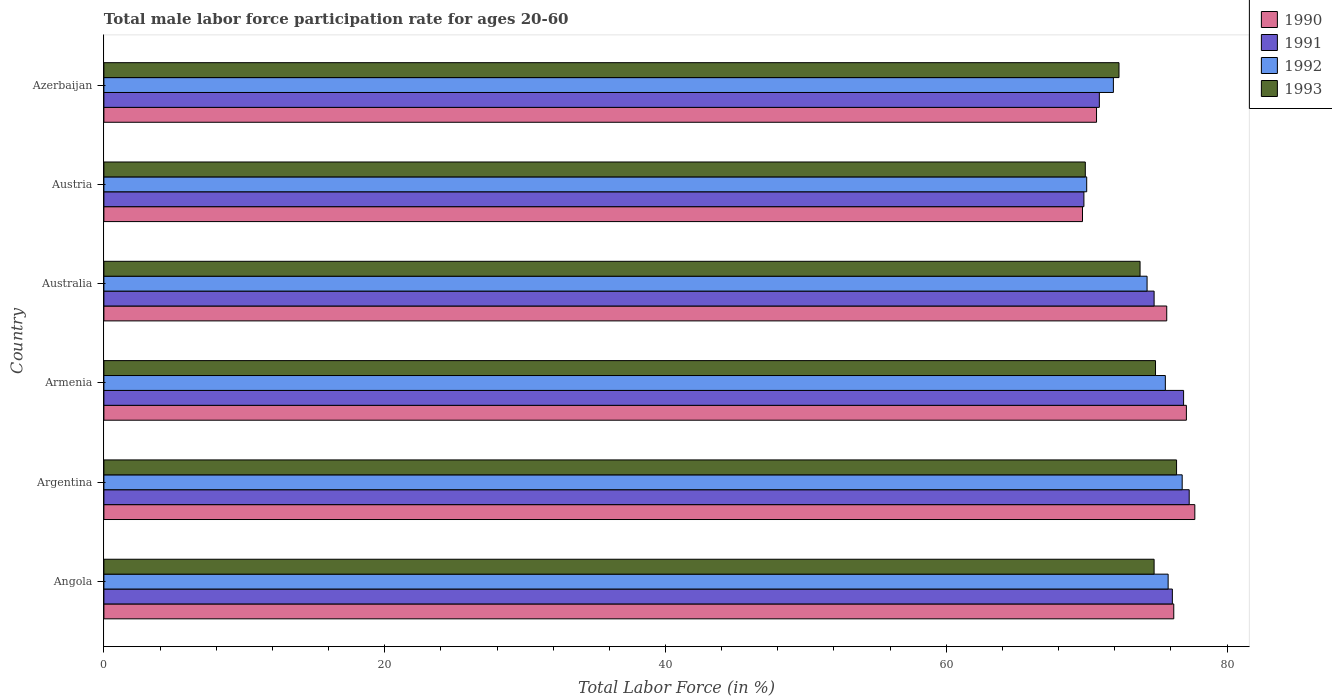How many groups of bars are there?
Give a very brief answer. 6. Are the number of bars per tick equal to the number of legend labels?
Give a very brief answer. Yes. Are the number of bars on each tick of the Y-axis equal?
Your answer should be compact. Yes. What is the label of the 1st group of bars from the top?
Provide a succinct answer. Azerbaijan. In how many cases, is the number of bars for a given country not equal to the number of legend labels?
Offer a very short reply. 0. Across all countries, what is the maximum male labor force participation rate in 1993?
Your answer should be very brief. 76.4. Across all countries, what is the minimum male labor force participation rate in 1991?
Provide a succinct answer. 69.8. In which country was the male labor force participation rate in 1991 maximum?
Keep it short and to the point. Argentina. What is the total male labor force participation rate in 1991 in the graph?
Your answer should be very brief. 445.8. What is the difference between the male labor force participation rate in 1991 in Argentina and that in Australia?
Keep it short and to the point. 2.5. What is the difference between the male labor force participation rate in 1991 in Azerbaijan and the male labor force participation rate in 1990 in Armenia?
Keep it short and to the point. -6.2. What is the average male labor force participation rate in 1990 per country?
Your answer should be compact. 74.52. What is the difference between the male labor force participation rate in 1993 and male labor force participation rate in 1992 in Australia?
Offer a terse response. -0.5. In how many countries, is the male labor force participation rate in 1990 greater than 28 %?
Provide a succinct answer. 6. What is the ratio of the male labor force participation rate in 1992 in Angola to that in Azerbaijan?
Provide a succinct answer. 1.05. Is the male labor force participation rate in 1992 in Angola less than that in Australia?
Your answer should be compact. No. What is the difference between the highest and the second highest male labor force participation rate in 1991?
Ensure brevity in your answer.  0.4. What is the difference between the highest and the lowest male labor force participation rate in 1991?
Keep it short and to the point. 7.5. Is the sum of the male labor force participation rate in 1992 in Angola and Austria greater than the maximum male labor force participation rate in 1991 across all countries?
Your answer should be compact. Yes. Are all the bars in the graph horizontal?
Make the answer very short. Yes. What is the difference between two consecutive major ticks on the X-axis?
Keep it short and to the point. 20. Does the graph contain grids?
Your answer should be very brief. No. Where does the legend appear in the graph?
Offer a very short reply. Top right. How many legend labels are there?
Provide a succinct answer. 4. How are the legend labels stacked?
Your answer should be very brief. Vertical. What is the title of the graph?
Keep it short and to the point. Total male labor force participation rate for ages 20-60. Does "1986" appear as one of the legend labels in the graph?
Offer a terse response. No. What is the label or title of the X-axis?
Ensure brevity in your answer.  Total Labor Force (in %). What is the label or title of the Y-axis?
Your response must be concise. Country. What is the Total Labor Force (in %) in 1990 in Angola?
Keep it short and to the point. 76.2. What is the Total Labor Force (in %) in 1991 in Angola?
Give a very brief answer. 76.1. What is the Total Labor Force (in %) in 1992 in Angola?
Provide a short and direct response. 75.8. What is the Total Labor Force (in %) in 1993 in Angola?
Make the answer very short. 74.8. What is the Total Labor Force (in %) of 1990 in Argentina?
Your answer should be very brief. 77.7. What is the Total Labor Force (in %) in 1991 in Argentina?
Ensure brevity in your answer.  77.3. What is the Total Labor Force (in %) in 1992 in Argentina?
Your answer should be very brief. 76.8. What is the Total Labor Force (in %) in 1993 in Argentina?
Ensure brevity in your answer.  76.4. What is the Total Labor Force (in %) of 1990 in Armenia?
Provide a short and direct response. 77.1. What is the Total Labor Force (in %) in 1991 in Armenia?
Ensure brevity in your answer.  76.9. What is the Total Labor Force (in %) in 1992 in Armenia?
Ensure brevity in your answer.  75.6. What is the Total Labor Force (in %) of 1993 in Armenia?
Give a very brief answer. 74.9. What is the Total Labor Force (in %) of 1990 in Australia?
Keep it short and to the point. 75.7. What is the Total Labor Force (in %) of 1991 in Australia?
Give a very brief answer. 74.8. What is the Total Labor Force (in %) of 1992 in Australia?
Your response must be concise. 74.3. What is the Total Labor Force (in %) of 1993 in Australia?
Your answer should be compact. 73.8. What is the Total Labor Force (in %) in 1990 in Austria?
Make the answer very short. 69.7. What is the Total Labor Force (in %) in 1991 in Austria?
Offer a very short reply. 69.8. What is the Total Labor Force (in %) in 1992 in Austria?
Ensure brevity in your answer.  70. What is the Total Labor Force (in %) of 1993 in Austria?
Your answer should be very brief. 69.9. What is the Total Labor Force (in %) in 1990 in Azerbaijan?
Make the answer very short. 70.7. What is the Total Labor Force (in %) of 1991 in Azerbaijan?
Give a very brief answer. 70.9. What is the Total Labor Force (in %) of 1992 in Azerbaijan?
Your answer should be very brief. 71.9. What is the Total Labor Force (in %) in 1993 in Azerbaijan?
Offer a terse response. 72.3. Across all countries, what is the maximum Total Labor Force (in %) in 1990?
Give a very brief answer. 77.7. Across all countries, what is the maximum Total Labor Force (in %) of 1991?
Offer a terse response. 77.3. Across all countries, what is the maximum Total Labor Force (in %) in 1992?
Give a very brief answer. 76.8. Across all countries, what is the maximum Total Labor Force (in %) in 1993?
Give a very brief answer. 76.4. Across all countries, what is the minimum Total Labor Force (in %) in 1990?
Give a very brief answer. 69.7. Across all countries, what is the minimum Total Labor Force (in %) in 1991?
Provide a short and direct response. 69.8. Across all countries, what is the minimum Total Labor Force (in %) in 1993?
Keep it short and to the point. 69.9. What is the total Total Labor Force (in %) of 1990 in the graph?
Keep it short and to the point. 447.1. What is the total Total Labor Force (in %) of 1991 in the graph?
Offer a terse response. 445.8. What is the total Total Labor Force (in %) in 1992 in the graph?
Your response must be concise. 444.4. What is the total Total Labor Force (in %) of 1993 in the graph?
Make the answer very short. 442.1. What is the difference between the Total Labor Force (in %) of 1990 in Angola and that in Argentina?
Provide a succinct answer. -1.5. What is the difference between the Total Labor Force (in %) of 1992 in Angola and that in Argentina?
Your answer should be compact. -1. What is the difference between the Total Labor Force (in %) in 1991 in Angola and that in Armenia?
Offer a very short reply. -0.8. What is the difference between the Total Labor Force (in %) in 1992 in Angola and that in Australia?
Your response must be concise. 1.5. What is the difference between the Total Labor Force (in %) of 1990 in Angola and that in Austria?
Keep it short and to the point. 6.5. What is the difference between the Total Labor Force (in %) in 1991 in Angola and that in Austria?
Your response must be concise. 6.3. What is the difference between the Total Labor Force (in %) of 1992 in Angola and that in Austria?
Ensure brevity in your answer.  5.8. What is the difference between the Total Labor Force (in %) of 1993 in Angola and that in Austria?
Provide a succinct answer. 4.9. What is the difference between the Total Labor Force (in %) of 1990 in Angola and that in Azerbaijan?
Offer a terse response. 5.5. What is the difference between the Total Labor Force (in %) of 1991 in Angola and that in Azerbaijan?
Your answer should be very brief. 5.2. What is the difference between the Total Labor Force (in %) of 1992 in Angola and that in Azerbaijan?
Your answer should be very brief. 3.9. What is the difference between the Total Labor Force (in %) in 1990 in Argentina and that in Australia?
Your response must be concise. 2. What is the difference between the Total Labor Force (in %) of 1991 in Argentina and that in Australia?
Your answer should be very brief. 2.5. What is the difference between the Total Labor Force (in %) of 1992 in Argentina and that in Australia?
Ensure brevity in your answer.  2.5. What is the difference between the Total Labor Force (in %) in 1993 in Argentina and that in Australia?
Offer a very short reply. 2.6. What is the difference between the Total Labor Force (in %) of 1990 in Argentina and that in Austria?
Give a very brief answer. 8. What is the difference between the Total Labor Force (in %) of 1991 in Argentina and that in Austria?
Your answer should be compact. 7.5. What is the difference between the Total Labor Force (in %) in 1992 in Argentina and that in Austria?
Provide a short and direct response. 6.8. What is the difference between the Total Labor Force (in %) of 1992 in Argentina and that in Azerbaijan?
Offer a terse response. 4.9. What is the difference between the Total Labor Force (in %) of 1990 in Armenia and that in Austria?
Offer a very short reply. 7.4. What is the difference between the Total Labor Force (in %) in 1991 in Armenia and that in Austria?
Ensure brevity in your answer.  7.1. What is the difference between the Total Labor Force (in %) of 1992 in Armenia and that in Austria?
Offer a terse response. 5.6. What is the difference between the Total Labor Force (in %) in 1991 in Armenia and that in Azerbaijan?
Offer a very short reply. 6. What is the difference between the Total Labor Force (in %) of 1992 in Armenia and that in Azerbaijan?
Offer a very short reply. 3.7. What is the difference between the Total Labor Force (in %) in 1993 in Armenia and that in Azerbaijan?
Provide a succinct answer. 2.6. What is the difference between the Total Labor Force (in %) in 1990 in Australia and that in Austria?
Ensure brevity in your answer.  6. What is the difference between the Total Labor Force (in %) of 1991 in Australia and that in Austria?
Provide a succinct answer. 5. What is the difference between the Total Labor Force (in %) of 1992 in Australia and that in Austria?
Give a very brief answer. 4.3. What is the difference between the Total Labor Force (in %) of 1992 in Australia and that in Azerbaijan?
Provide a short and direct response. 2.4. What is the difference between the Total Labor Force (in %) in 1993 in Australia and that in Azerbaijan?
Keep it short and to the point. 1.5. What is the difference between the Total Labor Force (in %) of 1990 in Austria and that in Azerbaijan?
Your answer should be compact. -1. What is the difference between the Total Labor Force (in %) of 1991 in Austria and that in Azerbaijan?
Provide a succinct answer. -1.1. What is the difference between the Total Labor Force (in %) of 1990 in Angola and the Total Labor Force (in %) of 1991 in Argentina?
Provide a short and direct response. -1.1. What is the difference between the Total Labor Force (in %) of 1990 in Angola and the Total Labor Force (in %) of 1992 in Argentina?
Your response must be concise. -0.6. What is the difference between the Total Labor Force (in %) of 1990 in Angola and the Total Labor Force (in %) of 1993 in Argentina?
Give a very brief answer. -0.2. What is the difference between the Total Labor Force (in %) in 1991 in Angola and the Total Labor Force (in %) in 1992 in Argentina?
Ensure brevity in your answer.  -0.7. What is the difference between the Total Labor Force (in %) of 1991 in Angola and the Total Labor Force (in %) of 1993 in Argentina?
Offer a very short reply. -0.3. What is the difference between the Total Labor Force (in %) in 1992 in Angola and the Total Labor Force (in %) in 1993 in Argentina?
Keep it short and to the point. -0.6. What is the difference between the Total Labor Force (in %) of 1990 in Angola and the Total Labor Force (in %) of 1991 in Armenia?
Make the answer very short. -0.7. What is the difference between the Total Labor Force (in %) of 1990 in Angola and the Total Labor Force (in %) of 1993 in Australia?
Keep it short and to the point. 2.4. What is the difference between the Total Labor Force (in %) in 1991 in Angola and the Total Labor Force (in %) in 1992 in Australia?
Your response must be concise. 1.8. What is the difference between the Total Labor Force (in %) in 1992 in Angola and the Total Labor Force (in %) in 1993 in Australia?
Offer a very short reply. 2. What is the difference between the Total Labor Force (in %) in 1990 in Angola and the Total Labor Force (in %) in 1991 in Azerbaijan?
Provide a short and direct response. 5.3. What is the difference between the Total Labor Force (in %) of 1992 in Angola and the Total Labor Force (in %) of 1993 in Azerbaijan?
Your answer should be very brief. 3.5. What is the difference between the Total Labor Force (in %) of 1990 in Argentina and the Total Labor Force (in %) of 1992 in Armenia?
Your response must be concise. 2.1. What is the difference between the Total Labor Force (in %) of 1990 in Argentina and the Total Labor Force (in %) of 1993 in Armenia?
Your response must be concise. 2.8. What is the difference between the Total Labor Force (in %) of 1991 in Argentina and the Total Labor Force (in %) of 1993 in Armenia?
Offer a very short reply. 2.4. What is the difference between the Total Labor Force (in %) in 1990 in Argentina and the Total Labor Force (in %) in 1993 in Australia?
Provide a short and direct response. 3.9. What is the difference between the Total Labor Force (in %) in 1990 in Argentina and the Total Labor Force (in %) in 1992 in Austria?
Give a very brief answer. 7.7. What is the difference between the Total Labor Force (in %) in 1991 in Argentina and the Total Labor Force (in %) in 1992 in Austria?
Offer a terse response. 7.3. What is the difference between the Total Labor Force (in %) of 1991 in Argentina and the Total Labor Force (in %) of 1993 in Austria?
Make the answer very short. 7.4. What is the difference between the Total Labor Force (in %) of 1992 in Argentina and the Total Labor Force (in %) of 1993 in Austria?
Offer a terse response. 6.9. What is the difference between the Total Labor Force (in %) of 1990 in Argentina and the Total Labor Force (in %) of 1992 in Azerbaijan?
Offer a terse response. 5.8. What is the difference between the Total Labor Force (in %) in 1992 in Argentina and the Total Labor Force (in %) in 1993 in Azerbaijan?
Offer a terse response. 4.5. What is the difference between the Total Labor Force (in %) in 1990 in Armenia and the Total Labor Force (in %) in 1993 in Australia?
Your answer should be very brief. 3.3. What is the difference between the Total Labor Force (in %) of 1991 in Armenia and the Total Labor Force (in %) of 1993 in Australia?
Offer a terse response. 3.1. What is the difference between the Total Labor Force (in %) of 1990 in Armenia and the Total Labor Force (in %) of 1993 in Austria?
Your response must be concise. 7.2. What is the difference between the Total Labor Force (in %) of 1991 in Armenia and the Total Labor Force (in %) of 1993 in Austria?
Give a very brief answer. 7. What is the difference between the Total Labor Force (in %) of 1992 in Armenia and the Total Labor Force (in %) of 1993 in Austria?
Offer a terse response. 5.7. What is the difference between the Total Labor Force (in %) in 1990 in Armenia and the Total Labor Force (in %) in 1991 in Azerbaijan?
Provide a succinct answer. 6.2. What is the difference between the Total Labor Force (in %) in 1992 in Armenia and the Total Labor Force (in %) in 1993 in Azerbaijan?
Your answer should be very brief. 3.3. What is the difference between the Total Labor Force (in %) in 1991 in Australia and the Total Labor Force (in %) in 1993 in Austria?
Keep it short and to the point. 4.9. What is the difference between the Total Labor Force (in %) in 1992 in Australia and the Total Labor Force (in %) in 1993 in Austria?
Provide a succinct answer. 4.4. What is the difference between the Total Labor Force (in %) of 1990 in Australia and the Total Labor Force (in %) of 1992 in Azerbaijan?
Offer a very short reply. 3.8. What is the difference between the Total Labor Force (in %) of 1990 in Australia and the Total Labor Force (in %) of 1993 in Azerbaijan?
Give a very brief answer. 3.4. What is the difference between the Total Labor Force (in %) in 1991 in Australia and the Total Labor Force (in %) in 1992 in Azerbaijan?
Your response must be concise. 2.9. What is the difference between the Total Labor Force (in %) of 1992 in Australia and the Total Labor Force (in %) of 1993 in Azerbaijan?
Your answer should be compact. 2. What is the difference between the Total Labor Force (in %) of 1990 in Austria and the Total Labor Force (in %) of 1991 in Azerbaijan?
Your answer should be very brief. -1.2. What is the difference between the Total Labor Force (in %) of 1991 in Austria and the Total Labor Force (in %) of 1992 in Azerbaijan?
Your response must be concise. -2.1. What is the average Total Labor Force (in %) in 1990 per country?
Offer a terse response. 74.52. What is the average Total Labor Force (in %) in 1991 per country?
Provide a short and direct response. 74.3. What is the average Total Labor Force (in %) in 1992 per country?
Ensure brevity in your answer.  74.07. What is the average Total Labor Force (in %) in 1993 per country?
Offer a terse response. 73.68. What is the difference between the Total Labor Force (in %) in 1990 and Total Labor Force (in %) in 1991 in Angola?
Your answer should be very brief. 0.1. What is the difference between the Total Labor Force (in %) of 1990 and Total Labor Force (in %) of 1992 in Angola?
Provide a succinct answer. 0.4. What is the difference between the Total Labor Force (in %) of 1991 and Total Labor Force (in %) of 1993 in Angola?
Your answer should be very brief. 1.3. What is the difference between the Total Labor Force (in %) in 1990 and Total Labor Force (in %) in 1992 in Argentina?
Ensure brevity in your answer.  0.9. What is the difference between the Total Labor Force (in %) of 1991 and Total Labor Force (in %) of 1992 in Argentina?
Provide a short and direct response. 0.5. What is the difference between the Total Labor Force (in %) in 1990 and Total Labor Force (in %) in 1991 in Armenia?
Ensure brevity in your answer.  0.2. What is the difference between the Total Labor Force (in %) of 1991 and Total Labor Force (in %) of 1993 in Armenia?
Provide a succinct answer. 2. What is the difference between the Total Labor Force (in %) in 1990 and Total Labor Force (in %) in 1993 in Australia?
Offer a very short reply. 1.9. What is the difference between the Total Labor Force (in %) of 1991 and Total Labor Force (in %) of 1992 in Australia?
Make the answer very short. 0.5. What is the difference between the Total Labor Force (in %) in 1991 and Total Labor Force (in %) in 1993 in Australia?
Keep it short and to the point. 1. What is the difference between the Total Labor Force (in %) of 1992 and Total Labor Force (in %) of 1993 in Australia?
Offer a terse response. 0.5. What is the difference between the Total Labor Force (in %) of 1990 and Total Labor Force (in %) of 1992 in Austria?
Make the answer very short. -0.3. What is the difference between the Total Labor Force (in %) of 1990 and Total Labor Force (in %) of 1991 in Azerbaijan?
Give a very brief answer. -0.2. What is the difference between the Total Labor Force (in %) in 1990 and Total Labor Force (in %) in 1992 in Azerbaijan?
Provide a succinct answer. -1.2. What is the difference between the Total Labor Force (in %) in 1991 and Total Labor Force (in %) in 1993 in Azerbaijan?
Your answer should be very brief. -1.4. What is the difference between the Total Labor Force (in %) in 1992 and Total Labor Force (in %) in 1993 in Azerbaijan?
Give a very brief answer. -0.4. What is the ratio of the Total Labor Force (in %) of 1990 in Angola to that in Argentina?
Provide a short and direct response. 0.98. What is the ratio of the Total Labor Force (in %) in 1991 in Angola to that in Argentina?
Make the answer very short. 0.98. What is the ratio of the Total Labor Force (in %) in 1993 in Angola to that in Argentina?
Your response must be concise. 0.98. What is the ratio of the Total Labor Force (in %) of 1990 in Angola to that in Armenia?
Offer a very short reply. 0.99. What is the ratio of the Total Labor Force (in %) of 1991 in Angola to that in Armenia?
Ensure brevity in your answer.  0.99. What is the ratio of the Total Labor Force (in %) of 1992 in Angola to that in Armenia?
Your answer should be compact. 1. What is the ratio of the Total Labor Force (in %) of 1993 in Angola to that in Armenia?
Provide a succinct answer. 1. What is the ratio of the Total Labor Force (in %) of 1990 in Angola to that in Australia?
Your answer should be compact. 1.01. What is the ratio of the Total Labor Force (in %) in 1991 in Angola to that in Australia?
Keep it short and to the point. 1.02. What is the ratio of the Total Labor Force (in %) of 1992 in Angola to that in Australia?
Your answer should be compact. 1.02. What is the ratio of the Total Labor Force (in %) in 1993 in Angola to that in Australia?
Make the answer very short. 1.01. What is the ratio of the Total Labor Force (in %) of 1990 in Angola to that in Austria?
Your answer should be compact. 1.09. What is the ratio of the Total Labor Force (in %) in 1991 in Angola to that in Austria?
Offer a terse response. 1.09. What is the ratio of the Total Labor Force (in %) of 1992 in Angola to that in Austria?
Offer a very short reply. 1.08. What is the ratio of the Total Labor Force (in %) in 1993 in Angola to that in Austria?
Your answer should be compact. 1.07. What is the ratio of the Total Labor Force (in %) in 1990 in Angola to that in Azerbaijan?
Your answer should be compact. 1.08. What is the ratio of the Total Labor Force (in %) in 1991 in Angola to that in Azerbaijan?
Your response must be concise. 1.07. What is the ratio of the Total Labor Force (in %) in 1992 in Angola to that in Azerbaijan?
Offer a terse response. 1.05. What is the ratio of the Total Labor Force (in %) in 1993 in Angola to that in Azerbaijan?
Ensure brevity in your answer.  1.03. What is the ratio of the Total Labor Force (in %) in 1991 in Argentina to that in Armenia?
Your answer should be very brief. 1.01. What is the ratio of the Total Labor Force (in %) in 1992 in Argentina to that in Armenia?
Offer a terse response. 1.02. What is the ratio of the Total Labor Force (in %) of 1993 in Argentina to that in Armenia?
Provide a short and direct response. 1.02. What is the ratio of the Total Labor Force (in %) in 1990 in Argentina to that in Australia?
Your answer should be very brief. 1.03. What is the ratio of the Total Labor Force (in %) in 1991 in Argentina to that in Australia?
Offer a very short reply. 1.03. What is the ratio of the Total Labor Force (in %) of 1992 in Argentina to that in Australia?
Keep it short and to the point. 1.03. What is the ratio of the Total Labor Force (in %) in 1993 in Argentina to that in Australia?
Offer a very short reply. 1.04. What is the ratio of the Total Labor Force (in %) of 1990 in Argentina to that in Austria?
Your response must be concise. 1.11. What is the ratio of the Total Labor Force (in %) of 1991 in Argentina to that in Austria?
Your answer should be very brief. 1.11. What is the ratio of the Total Labor Force (in %) of 1992 in Argentina to that in Austria?
Provide a succinct answer. 1.1. What is the ratio of the Total Labor Force (in %) in 1993 in Argentina to that in Austria?
Ensure brevity in your answer.  1.09. What is the ratio of the Total Labor Force (in %) of 1990 in Argentina to that in Azerbaijan?
Your answer should be compact. 1.1. What is the ratio of the Total Labor Force (in %) in 1991 in Argentina to that in Azerbaijan?
Offer a terse response. 1.09. What is the ratio of the Total Labor Force (in %) of 1992 in Argentina to that in Azerbaijan?
Provide a short and direct response. 1.07. What is the ratio of the Total Labor Force (in %) of 1993 in Argentina to that in Azerbaijan?
Make the answer very short. 1.06. What is the ratio of the Total Labor Force (in %) in 1990 in Armenia to that in Australia?
Keep it short and to the point. 1.02. What is the ratio of the Total Labor Force (in %) of 1991 in Armenia to that in Australia?
Your answer should be very brief. 1.03. What is the ratio of the Total Labor Force (in %) in 1992 in Armenia to that in Australia?
Keep it short and to the point. 1.02. What is the ratio of the Total Labor Force (in %) in 1993 in Armenia to that in Australia?
Your answer should be very brief. 1.01. What is the ratio of the Total Labor Force (in %) of 1990 in Armenia to that in Austria?
Your response must be concise. 1.11. What is the ratio of the Total Labor Force (in %) in 1991 in Armenia to that in Austria?
Give a very brief answer. 1.1. What is the ratio of the Total Labor Force (in %) in 1992 in Armenia to that in Austria?
Offer a very short reply. 1.08. What is the ratio of the Total Labor Force (in %) in 1993 in Armenia to that in Austria?
Offer a terse response. 1.07. What is the ratio of the Total Labor Force (in %) in 1990 in Armenia to that in Azerbaijan?
Offer a very short reply. 1.09. What is the ratio of the Total Labor Force (in %) in 1991 in Armenia to that in Azerbaijan?
Keep it short and to the point. 1.08. What is the ratio of the Total Labor Force (in %) in 1992 in Armenia to that in Azerbaijan?
Your answer should be very brief. 1.05. What is the ratio of the Total Labor Force (in %) in 1993 in Armenia to that in Azerbaijan?
Provide a short and direct response. 1.04. What is the ratio of the Total Labor Force (in %) in 1990 in Australia to that in Austria?
Your answer should be compact. 1.09. What is the ratio of the Total Labor Force (in %) in 1991 in Australia to that in Austria?
Your answer should be very brief. 1.07. What is the ratio of the Total Labor Force (in %) of 1992 in Australia to that in Austria?
Your answer should be very brief. 1.06. What is the ratio of the Total Labor Force (in %) in 1993 in Australia to that in Austria?
Offer a very short reply. 1.06. What is the ratio of the Total Labor Force (in %) of 1990 in Australia to that in Azerbaijan?
Offer a very short reply. 1.07. What is the ratio of the Total Labor Force (in %) in 1991 in Australia to that in Azerbaijan?
Keep it short and to the point. 1.05. What is the ratio of the Total Labor Force (in %) in 1992 in Australia to that in Azerbaijan?
Provide a short and direct response. 1.03. What is the ratio of the Total Labor Force (in %) in 1993 in Australia to that in Azerbaijan?
Provide a short and direct response. 1.02. What is the ratio of the Total Labor Force (in %) in 1990 in Austria to that in Azerbaijan?
Keep it short and to the point. 0.99. What is the ratio of the Total Labor Force (in %) of 1991 in Austria to that in Azerbaijan?
Offer a very short reply. 0.98. What is the ratio of the Total Labor Force (in %) in 1992 in Austria to that in Azerbaijan?
Give a very brief answer. 0.97. What is the ratio of the Total Labor Force (in %) in 1993 in Austria to that in Azerbaijan?
Ensure brevity in your answer.  0.97. What is the difference between the highest and the second highest Total Labor Force (in %) in 1992?
Your response must be concise. 1. What is the difference between the highest and the second highest Total Labor Force (in %) of 1993?
Your answer should be very brief. 1.5. What is the difference between the highest and the lowest Total Labor Force (in %) in 1990?
Your answer should be compact. 8. What is the difference between the highest and the lowest Total Labor Force (in %) in 1991?
Your answer should be very brief. 7.5. What is the difference between the highest and the lowest Total Labor Force (in %) in 1992?
Make the answer very short. 6.8. What is the difference between the highest and the lowest Total Labor Force (in %) of 1993?
Offer a very short reply. 6.5. 